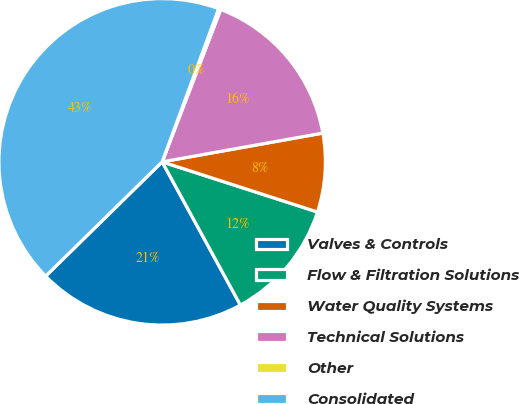Convert chart to OTSL. <chart><loc_0><loc_0><loc_500><loc_500><pie_chart><fcel>Valves & Controls<fcel>Flow & Filtration Solutions<fcel>Water Quality Systems<fcel>Technical Solutions<fcel>Other<fcel>Consolidated<nl><fcel>20.61%<fcel>12.07%<fcel>7.79%<fcel>16.34%<fcel>0.22%<fcel>42.97%<nl></chart> 